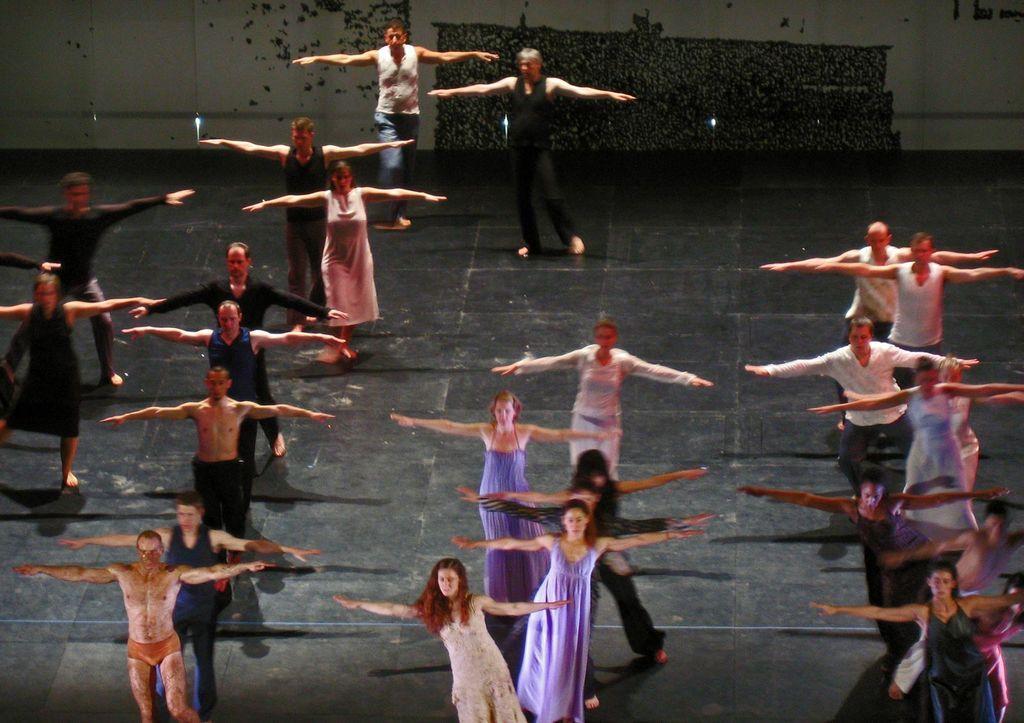In one or two sentences, can you explain what this image depicts? This picture is clicked inside the hall and we can see the group of people seems to be dancing. In the background we can see the wall and some other objects. 